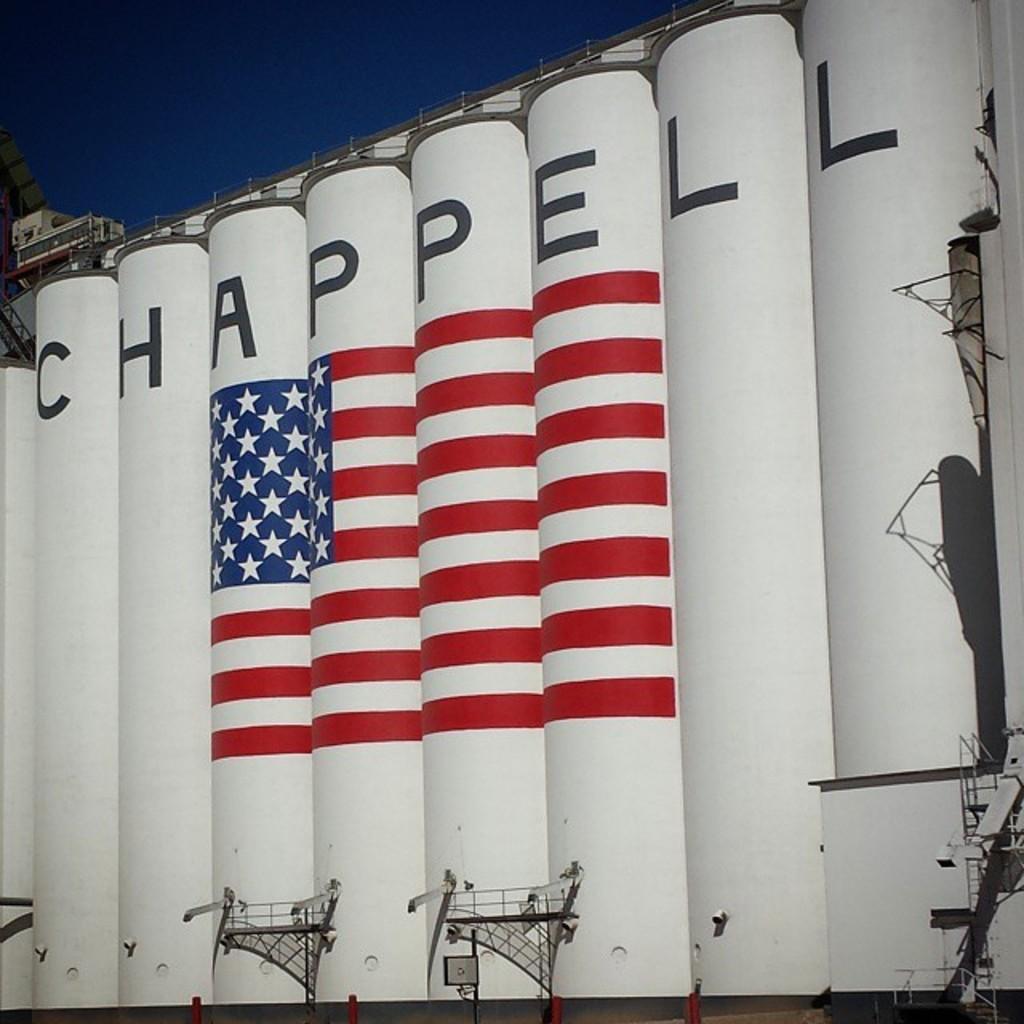Could you give a brief overview of what you see in this image? In this picture we can see shipyard are there. At the top of the image sky is there. 